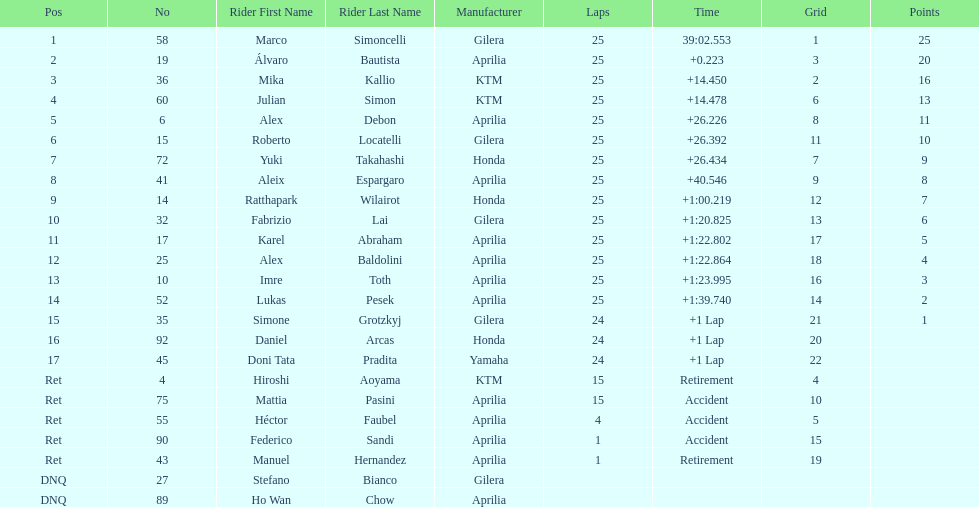What is the total number of rider? 24. 